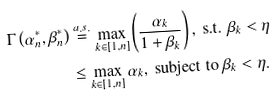<formula> <loc_0><loc_0><loc_500><loc_500>\Gamma \left ( \alpha _ { n } ^ { * } , \beta _ { n } ^ { * } \right ) & \stackrel { a . s . } { = } \max _ { k \in [ 1 , n ] } \left ( \frac { \alpha _ { k } } { 1 + \beta _ { k } } \right ) , \text { s.t. $\beta_{k}<\eta$} \\ & \leq \max _ { k \in [ 1 , n ] } \alpha _ { k } , \text { subject to $\beta_{k}<\eta$} .</formula> 